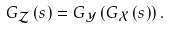<formula> <loc_0><loc_0><loc_500><loc_500>G _ { \mathcal { Z } } \left ( s \right ) = G _ { \mathcal { Y } } \left ( G _ { \mathcal { X } } \left ( s \right ) \right ) .</formula> 